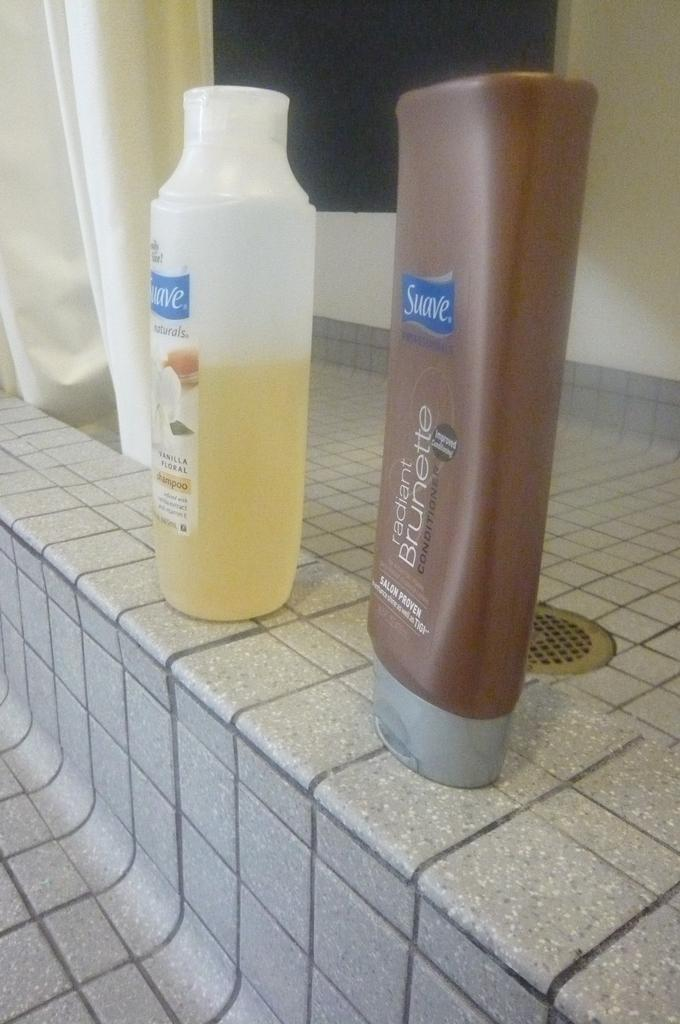What type of room is shown in the image? The image depicts a washroom. What can be found on the tiles in the washroom? There are two bottles on the tiles, one containing shampoo and the other containing conditioner. What is visible in the background of the image? There is a sink in the background. What color is the wall in the background? The wall in the background is cream-colored. What type of covering is present in the washroom? There is a curtain in the washroom. What type of company is conducting a meeting in the washroom? There is no company or meeting present in the image; it depicts a washroom with shampoo, conditioner, a sink, a cream-colored wall, and a curtain. What type of twig can be seen in the image? There are no twigs present in the image. 